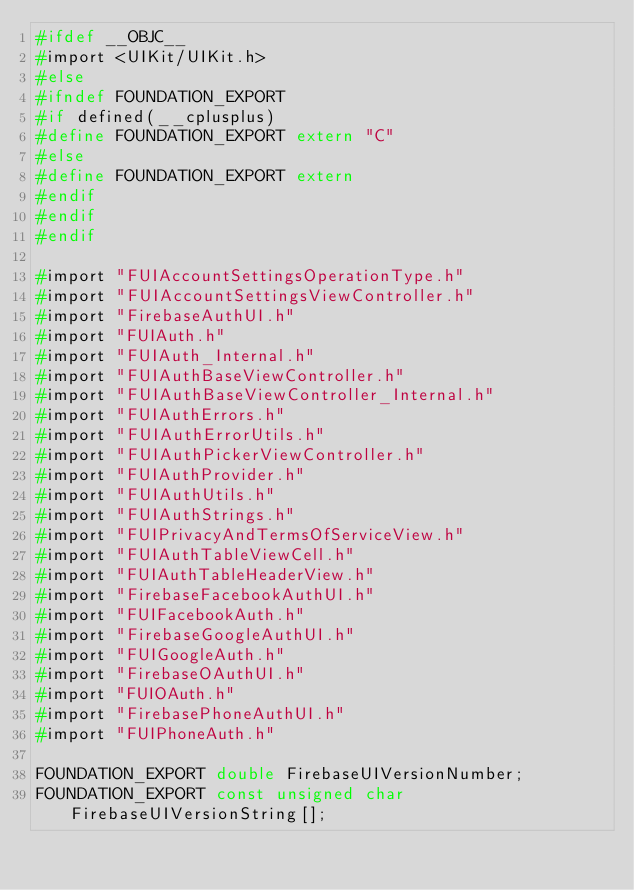<code> <loc_0><loc_0><loc_500><loc_500><_C_>#ifdef __OBJC__
#import <UIKit/UIKit.h>
#else
#ifndef FOUNDATION_EXPORT
#if defined(__cplusplus)
#define FOUNDATION_EXPORT extern "C"
#else
#define FOUNDATION_EXPORT extern
#endif
#endif
#endif

#import "FUIAccountSettingsOperationType.h"
#import "FUIAccountSettingsViewController.h"
#import "FirebaseAuthUI.h"
#import "FUIAuth.h"
#import "FUIAuth_Internal.h"
#import "FUIAuthBaseViewController.h"
#import "FUIAuthBaseViewController_Internal.h"
#import "FUIAuthErrors.h"
#import "FUIAuthErrorUtils.h"
#import "FUIAuthPickerViewController.h"
#import "FUIAuthProvider.h"
#import "FUIAuthUtils.h"
#import "FUIAuthStrings.h"
#import "FUIPrivacyAndTermsOfServiceView.h"
#import "FUIAuthTableViewCell.h"
#import "FUIAuthTableHeaderView.h"
#import "FirebaseFacebookAuthUI.h"
#import "FUIFacebookAuth.h"
#import "FirebaseGoogleAuthUI.h"
#import "FUIGoogleAuth.h"
#import "FirebaseOAuthUI.h"
#import "FUIOAuth.h"
#import "FirebasePhoneAuthUI.h"
#import "FUIPhoneAuth.h"

FOUNDATION_EXPORT double FirebaseUIVersionNumber;
FOUNDATION_EXPORT const unsigned char FirebaseUIVersionString[];

</code> 